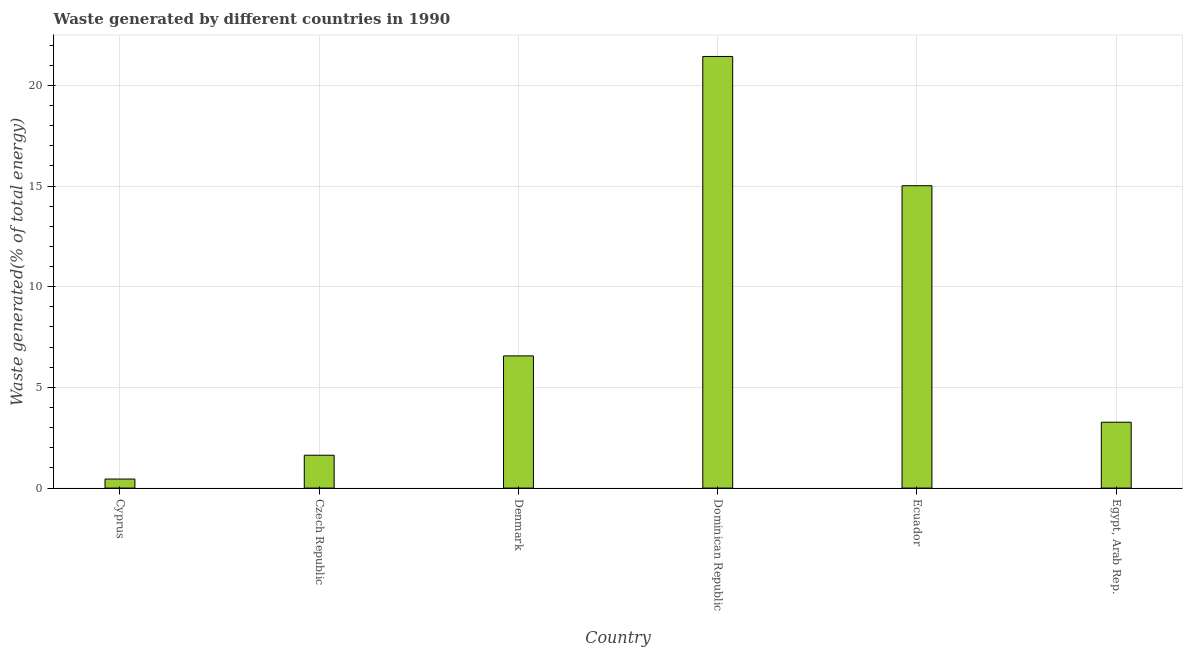Does the graph contain any zero values?
Your response must be concise. No. What is the title of the graph?
Provide a short and direct response. Waste generated by different countries in 1990. What is the label or title of the Y-axis?
Provide a short and direct response. Waste generated(% of total energy). What is the amount of waste generated in Ecuador?
Your answer should be very brief. 15.01. Across all countries, what is the maximum amount of waste generated?
Your answer should be very brief. 21.43. Across all countries, what is the minimum amount of waste generated?
Ensure brevity in your answer.  0.45. In which country was the amount of waste generated maximum?
Make the answer very short. Dominican Republic. In which country was the amount of waste generated minimum?
Keep it short and to the point. Cyprus. What is the sum of the amount of waste generated?
Give a very brief answer. 48.37. What is the difference between the amount of waste generated in Czech Republic and Dominican Republic?
Provide a succinct answer. -19.8. What is the average amount of waste generated per country?
Your answer should be compact. 8.06. What is the median amount of waste generated?
Your answer should be very brief. 4.92. In how many countries, is the amount of waste generated greater than 20 %?
Give a very brief answer. 1. What is the ratio of the amount of waste generated in Dominican Republic to that in Egypt, Arab Rep.?
Your answer should be very brief. 6.55. Is the amount of waste generated in Dominican Republic less than that in Ecuador?
Keep it short and to the point. No. What is the difference between the highest and the second highest amount of waste generated?
Your answer should be very brief. 6.42. Is the sum of the amount of waste generated in Dominican Republic and Ecuador greater than the maximum amount of waste generated across all countries?
Provide a short and direct response. Yes. What is the difference between the highest and the lowest amount of waste generated?
Make the answer very short. 20.98. How many bars are there?
Offer a terse response. 6. What is the difference between two consecutive major ticks on the Y-axis?
Make the answer very short. 5. Are the values on the major ticks of Y-axis written in scientific E-notation?
Provide a succinct answer. No. What is the Waste generated(% of total energy) in Cyprus?
Make the answer very short. 0.45. What is the Waste generated(% of total energy) in Czech Republic?
Give a very brief answer. 1.63. What is the Waste generated(% of total energy) in Denmark?
Your answer should be compact. 6.56. What is the Waste generated(% of total energy) of Dominican Republic?
Your answer should be compact. 21.43. What is the Waste generated(% of total energy) in Ecuador?
Your response must be concise. 15.01. What is the Waste generated(% of total energy) in Egypt, Arab Rep.?
Keep it short and to the point. 3.27. What is the difference between the Waste generated(% of total energy) in Cyprus and Czech Republic?
Provide a succinct answer. -1.18. What is the difference between the Waste generated(% of total energy) in Cyprus and Denmark?
Keep it short and to the point. -6.11. What is the difference between the Waste generated(% of total energy) in Cyprus and Dominican Republic?
Offer a terse response. -20.98. What is the difference between the Waste generated(% of total energy) in Cyprus and Ecuador?
Your response must be concise. -14.57. What is the difference between the Waste generated(% of total energy) in Cyprus and Egypt, Arab Rep.?
Give a very brief answer. -2.82. What is the difference between the Waste generated(% of total energy) in Czech Republic and Denmark?
Offer a very short reply. -4.93. What is the difference between the Waste generated(% of total energy) in Czech Republic and Dominican Republic?
Your answer should be very brief. -19.8. What is the difference between the Waste generated(% of total energy) in Czech Republic and Ecuador?
Your answer should be compact. -13.38. What is the difference between the Waste generated(% of total energy) in Czech Republic and Egypt, Arab Rep.?
Offer a terse response. -1.64. What is the difference between the Waste generated(% of total energy) in Denmark and Dominican Republic?
Offer a terse response. -14.87. What is the difference between the Waste generated(% of total energy) in Denmark and Ecuador?
Offer a terse response. -8.45. What is the difference between the Waste generated(% of total energy) in Denmark and Egypt, Arab Rep.?
Provide a short and direct response. 3.29. What is the difference between the Waste generated(% of total energy) in Dominican Republic and Ecuador?
Keep it short and to the point. 6.42. What is the difference between the Waste generated(% of total energy) in Dominican Republic and Egypt, Arab Rep.?
Provide a succinct answer. 18.16. What is the difference between the Waste generated(% of total energy) in Ecuador and Egypt, Arab Rep.?
Your answer should be compact. 11.74. What is the ratio of the Waste generated(% of total energy) in Cyprus to that in Czech Republic?
Make the answer very short. 0.28. What is the ratio of the Waste generated(% of total energy) in Cyprus to that in Denmark?
Offer a very short reply. 0.07. What is the ratio of the Waste generated(% of total energy) in Cyprus to that in Dominican Republic?
Give a very brief answer. 0.02. What is the ratio of the Waste generated(% of total energy) in Cyprus to that in Ecuador?
Your answer should be compact. 0.03. What is the ratio of the Waste generated(% of total energy) in Cyprus to that in Egypt, Arab Rep.?
Ensure brevity in your answer.  0.14. What is the ratio of the Waste generated(% of total energy) in Czech Republic to that in Denmark?
Provide a succinct answer. 0.25. What is the ratio of the Waste generated(% of total energy) in Czech Republic to that in Dominican Republic?
Your answer should be compact. 0.08. What is the ratio of the Waste generated(% of total energy) in Czech Republic to that in Ecuador?
Provide a short and direct response. 0.11. What is the ratio of the Waste generated(% of total energy) in Czech Republic to that in Egypt, Arab Rep.?
Your answer should be very brief. 0.5. What is the ratio of the Waste generated(% of total energy) in Denmark to that in Dominican Republic?
Ensure brevity in your answer.  0.31. What is the ratio of the Waste generated(% of total energy) in Denmark to that in Ecuador?
Provide a succinct answer. 0.44. What is the ratio of the Waste generated(% of total energy) in Denmark to that in Egypt, Arab Rep.?
Ensure brevity in your answer.  2.01. What is the ratio of the Waste generated(% of total energy) in Dominican Republic to that in Ecuador?
Provide a short and direct response. 1.43. What is the ratio of the Waste generated(% of total energy) in Dominican Republic to that in Egypt, Arab Rep.?
Your answer should be compact. 6.55. What is the ratio of the Waste generated(% of total energy) in Ecuador to that in Egypt, Arab Rep.?
Make the answer very short. 4.59. 